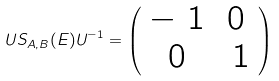Convert formula to latex. <formula><loc_0><loc_0><loc_500><loc_500>U S _ { A , B } ( E ) U ^ { - 1 } = \left ( \begin{array} { c c } - \ 1 & 0 \\ 0 & \ 1 \end{array} \right )</formula> 